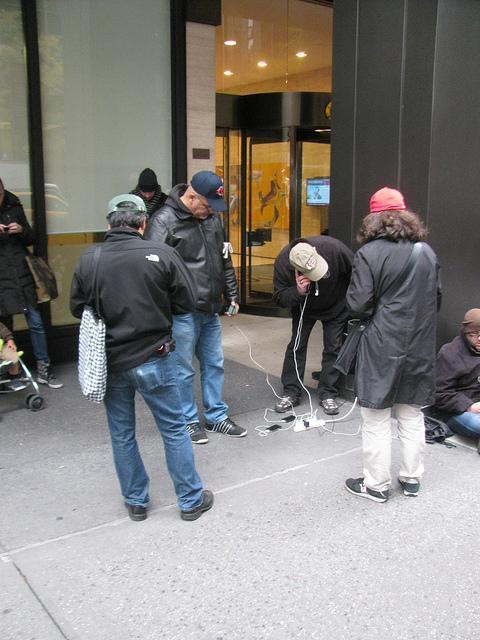How many of them are wearing baseball caps?
Give a very brief answer. 4. How many people can be seen?
Give a very brief answer. 6. 